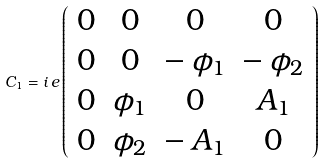Convert formula to latex. <formula><loc_0><loc_0><loc_500><loc_500>C _ { 1 } = i \, e \left ( \begin{array} { c c c c } 0 & 0 & 0 & 0 \\ 0 & 0 & - \, \phi _ { 1 } & - \, \phi _ { 2 } \\ 0 & \phi _ { 1 } & 0 & A _ { 1 } \\ 0 & \phi _ { 2 } & - \, A _ { 1 } & 0 \end{array} \right )</formula> 